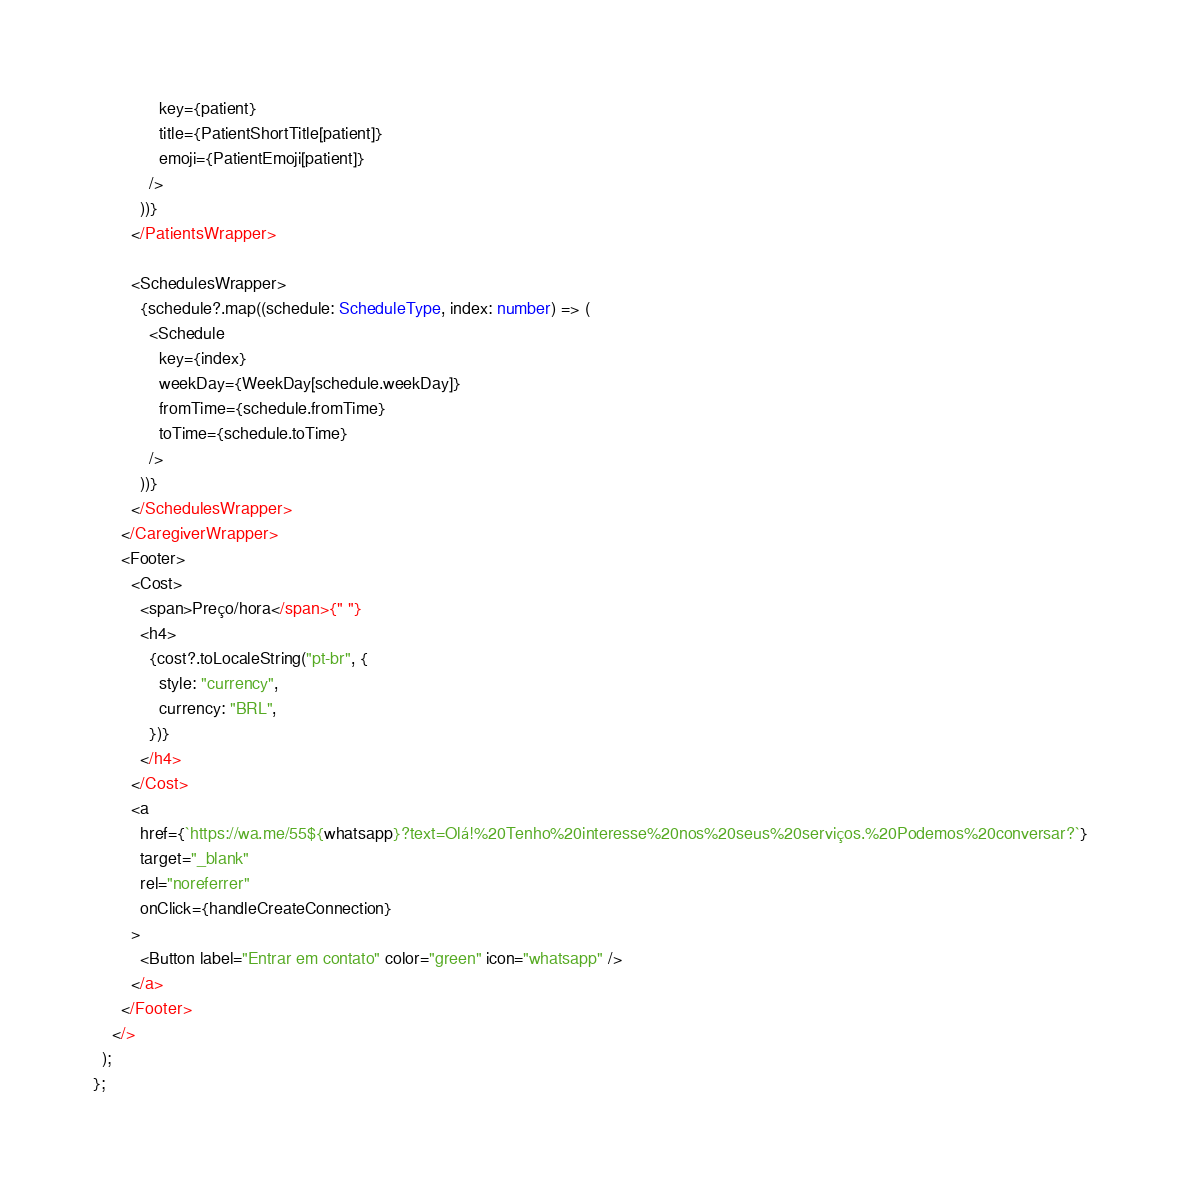Convert code to text. <code><loc_0><loc_0><loc_500><loc_500><_TypeScript_>              key={patient}
              title={PatientShortTitle[patient]}
              emoji={PatientEmoji[patient]}
            />
          ))}
        </PatientsWrapper>

        <SchedulesWrapper>
          {schedule?.map((schedule: ScheduleType, index: number) => (
            <Schedule
              key={index}
              weekDay={WeekDay[schedule.weekDay]}
              fromTime={schedule.fromTime}
              toTime={schedule.toTime}
            />
          ))}
        </SchedulesWrapper>
      </CaregiverWrapper>
      <Footer>
        <Cost>
          <span>Preço/hora</span>{" "}
          <h4>
            {cost?.toLocaleString("pt-br", {
              style: "currency",
              currency: "BRL",
            })}
          </h4>
        </Cost>
        <a
          href={`https://wa.me/55${whatsapp}?text=Olá!%20Tenho%20interesse%20nos%20seus%20serviços.%20Podemos%20conversar?`}
          target="_blank"
          rel="noreferrer"
          onClick={handleCreateConnection}
        >
          <Button label="Entrar em contato" color="green" icon="whatsapp" />
        </a>
      </Footer>
    </>
  );
};
</code> 